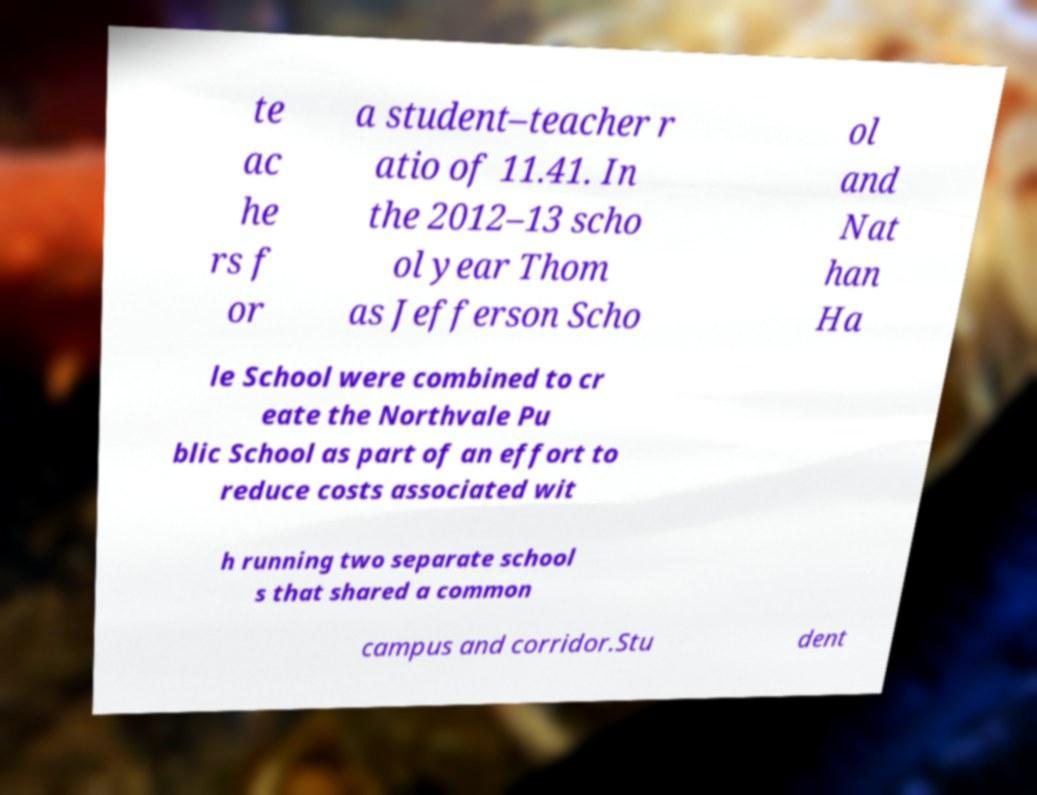Please read and relay the text visible in this image. What does it say? te ac he rs f or a student–teacher r atio of 11.41. In the 2012–13 scho ol year Thom as Jefferson Scho ol and Nat han Ha le School were combined to cr eate the Northvale Pu blic School as part of an effort to reduce costs associated wit h running two separate school s that shared a common campus and corridor.Stu dent 